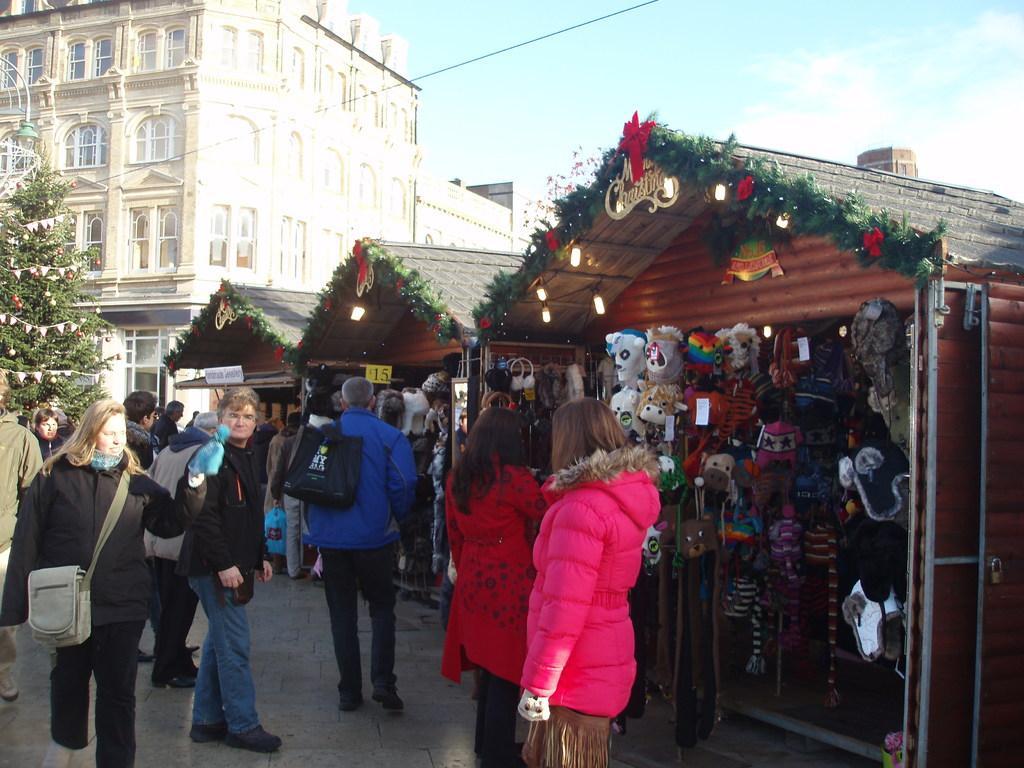Describe this image in one or two sentences. In this image, there are a few people, buildings. We can see some stories with some objects like toys. We can see the ground and a Christmas tree on the left. We can see a wire and the sky with clouds. 